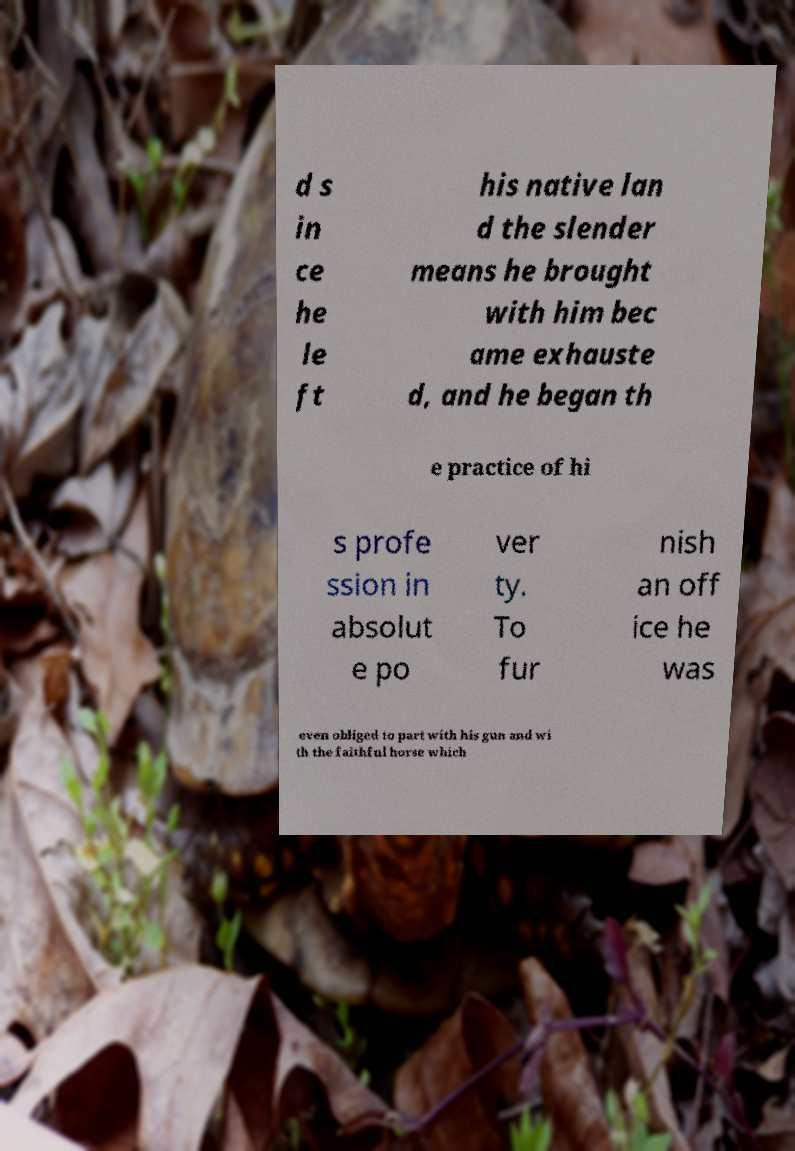Could you extract and type out the text from this image? d s in ce he le ft his native lan d the slender means he brought with him bec ame exhauste d, and he began th e practice of hi s profe ssion in absolut e po ver ty. To fur nish an off ice he was even obliged to part with his gun and wi th the faithful horse which 